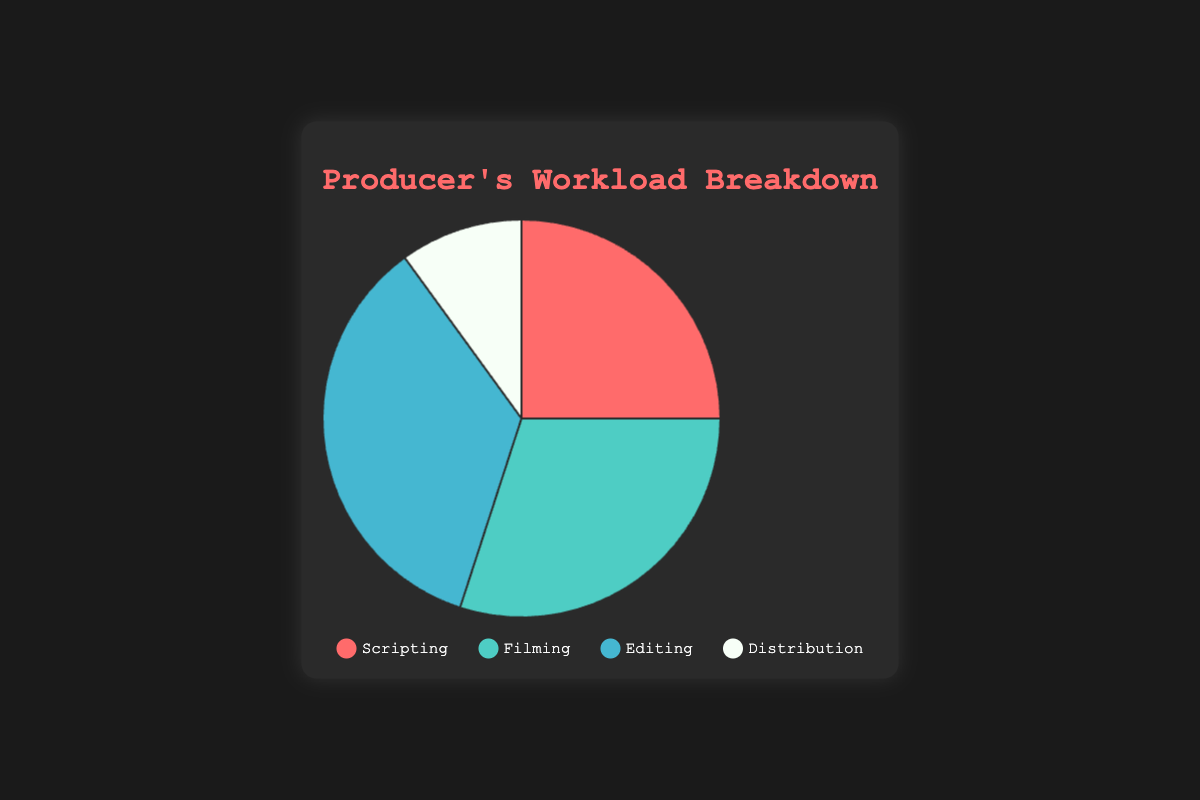Which activity takes up the smallest percentage of the workload? By looking at the pie chart, we can identify the smallest slice or the segment with the smallest percentage label. Distribution is labeled as 10%, which is the smallest compared to Scripting, Filming, and Editing.
Answer: Distribution What is the combined percentage of time spent on Scripting and Filming? To find the combined percentage, add the percentages for Scripting (25%) and Filming (30%). 25% + 30% = 55%.
Answer: 55% Which activities combined take up more than half of the workload? We need to determine which activities, when their percentages are added, exceed 50%. Editing (35%) and Filming (30%) individually are checked first. The combination (35% + 30% = 65%) is more than half.
Answer: Editing, Filming How does the time spent on Editing compare to the time spent on Scripting? Compare the percentages of Editing (35%) and Scripting (25%). 35% is greater than 25%, so more time is spent on Editing.
Answer: Editing > Scripting What is the difference in the workload percentage between Filming and Distribution? Calculate the difference between Filming (30%) and Distribution (10%). Subtract the smaller percentage from the larger one: 30% - 10% = 20%.
Answer: 20% Which activity uses the red color in the chart? By looking at the color legend, the activity associated with the red color is identified. In this chart, red is associated with Scripting.
Answer: Scripting What is the total workload percentage for activities excluding Distribution? To find the total, sum the percentages of Scripting (25%), Filming (30%), and Editing (35%). 25% + 30% + 35% = 90%.
Answer: 90% Is the time spent on Editing alone more than the combined time spent on Scripting and Distribution? Compare the percentage for Editing (35%) to the combined percentage of Scripting (25%) and Distribution (10%). 25% + 10% = 35%, so Editing alone is not more but equal.
Answer: No, equal Can you rank the activities from the largest to the smallest percentage of workload? List the activities by their percentages: Editing (35%), Filming (30%), Scripting (25%), and Distribution (10%).
Answer: Editing, Filming, Scripting, Distribution What fraction of the workload is dedicated to Filming relative to the total workload? Percentage of Filming (30%) relative to total 100% can be expressed as a fraction. 30% is 30 out of 100, which simplifies to 3/10.
Answer: 3/10 